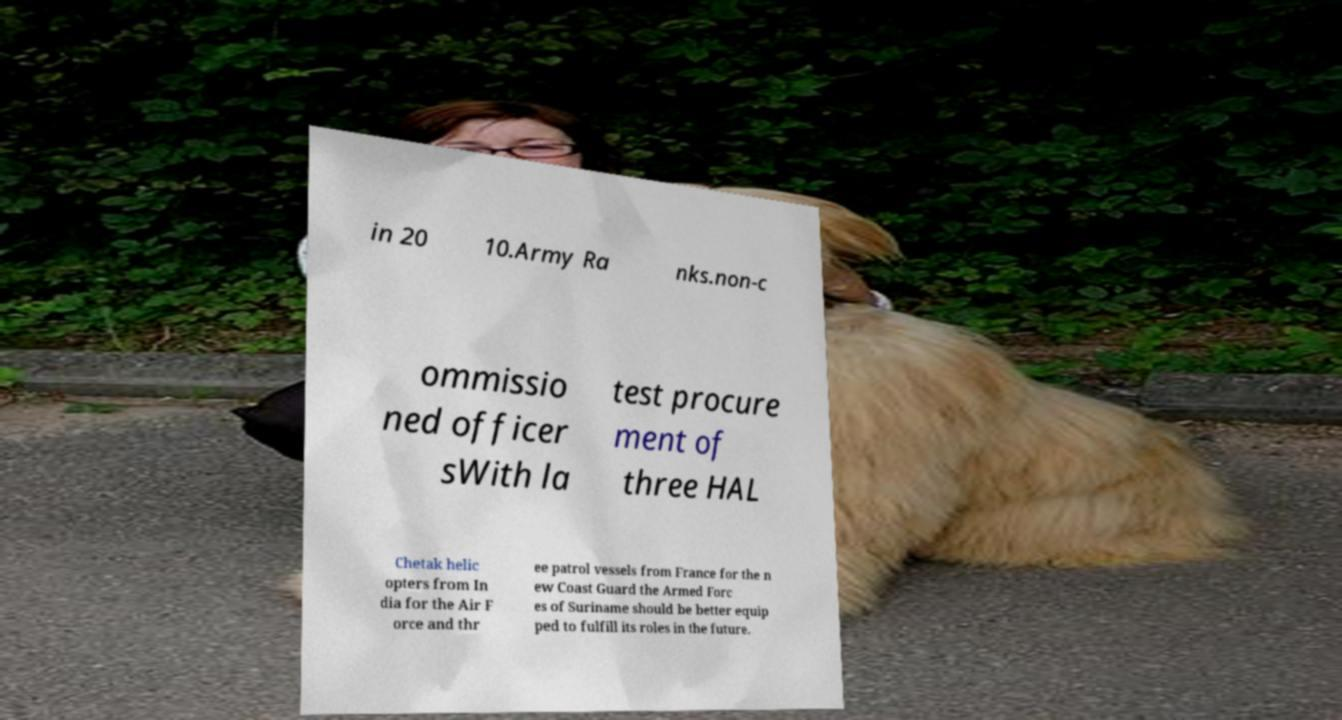Please read and relay the text visible in this image. What does it say? in 20 10.Army Ra nks.non-c ommissio ned officer sWith la test procure ment of three HAL Chetak helic opters from In dia for the Air F orce and thr ee patrol vessels from France for the n ew Coast Guard the Armed Forc es of Suriname should be better equip ped to fulfill its roles in the future. 